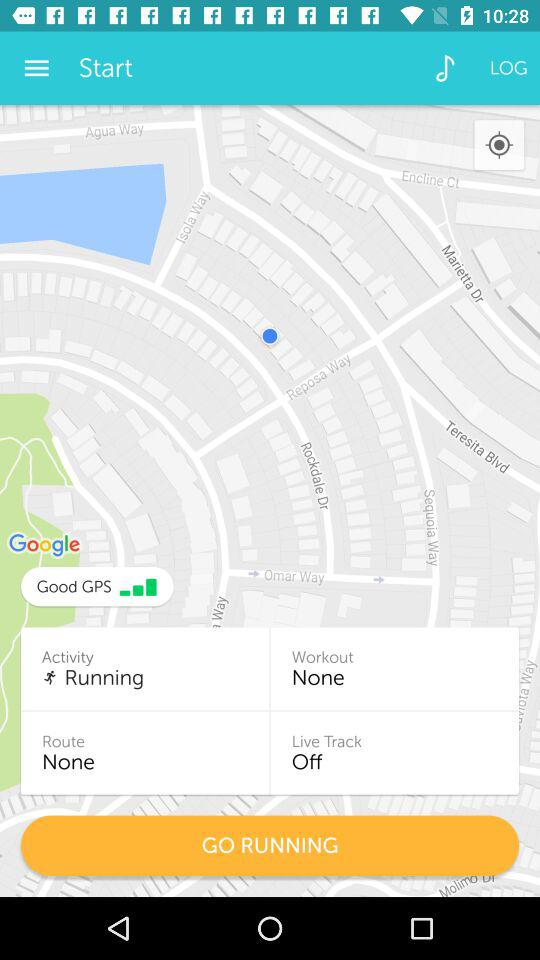What is the activity? The activity is running. 